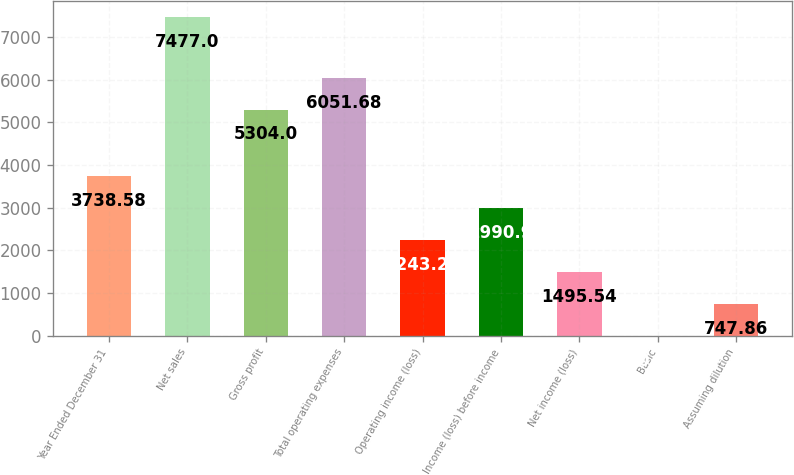<chart> <loc_0><loc_0><loc_500><loc_500><bar_chart><fcel>Year Ended December 31<fcel>Net sales<fcel>Gross profit<fcel>Total operating expenses<fcel>Operating income (loss)<fcel>Income (loss) before income<fcel>Net income (loss)<fcel>Basic<fcel>Assuming dilution<nl><fcel>3738.58<fcel>7477<fcel>5304<fcel>6051.68<fcel>2243.22<fcel>2990.9<fcel>1495.54<fcel>0.18<fcel>747.86<nl></chart> 